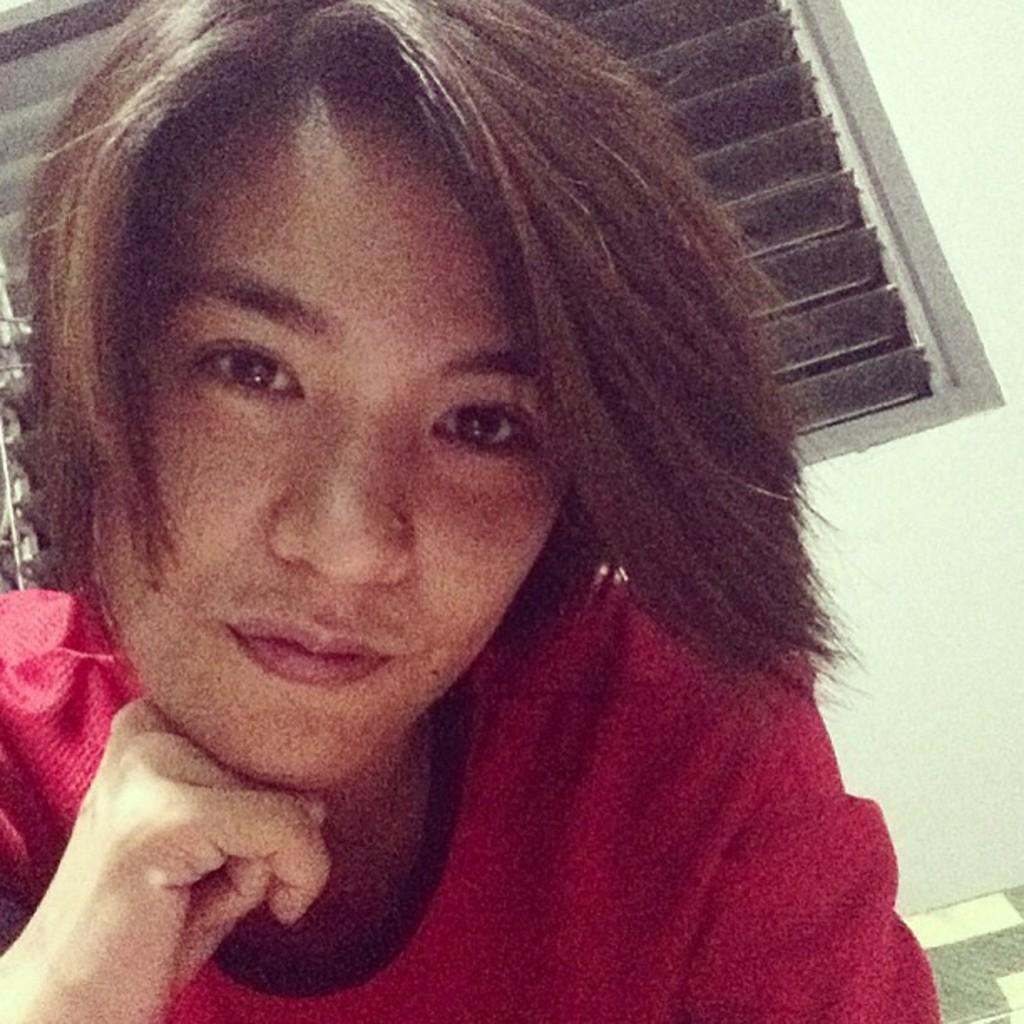Who or what is in the image? There is a person in the image. What is the person wearing? The person is wearing a red t-shirt. What can be seen behind the person? There is a window behind the person. What color is the wall on the right side of the image? The wall on the right side of the image is painted white. How many icicles are hanging from the person's red t-shirt in the image? There are no icicles present in the image, as it is not a cold environment where icicles would form. 